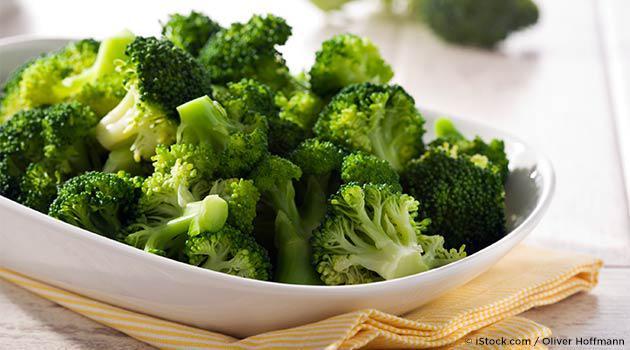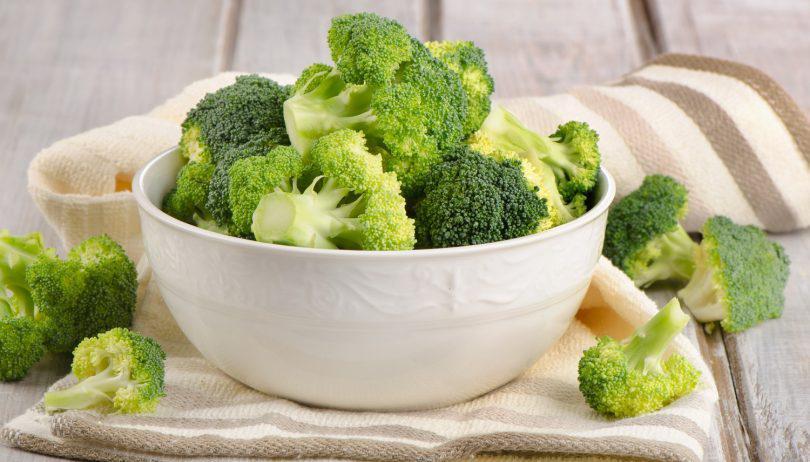The first image is the image on the left, the second image is the image on the right. Given the left and right images, does the statement "Each image shows broccoli florets in a white container, and one image shows broccoli florets in an oblong-shaped bowl." hold true? Answer yes or no. Yes. 